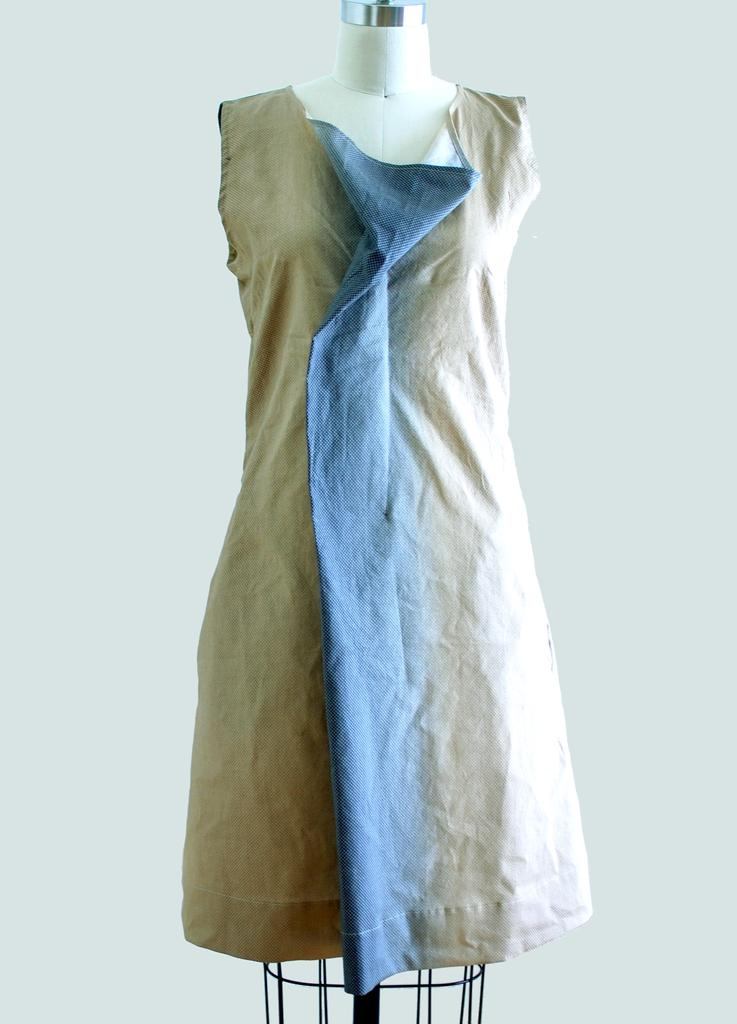What is displayed on the mannequin in the image? There is a dress on a mannequin in the image. What can be seen behind the mannequin? There is a wall visible in the image. What type of bubble can be seen floating near the dress in the image? There is no bubble present in the image. 